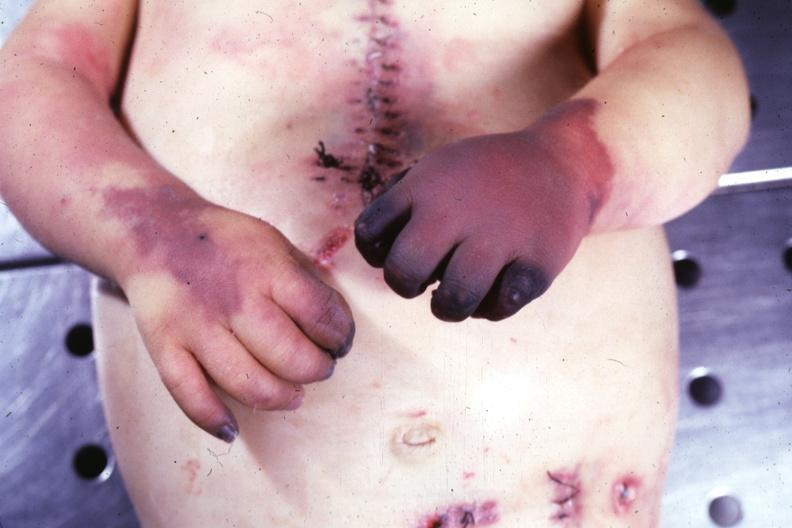what are present?
Answer the question using a single word or phrase. Extremities 